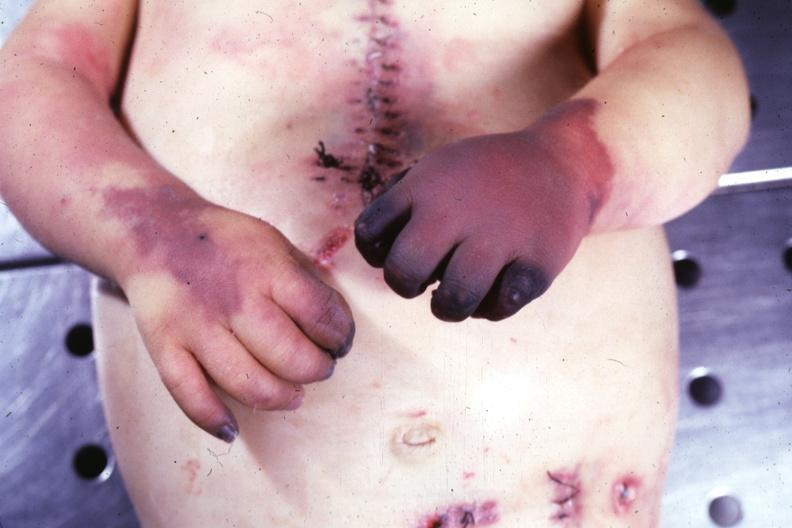what are present?
Answer the question using a single word or phrase. Extremities 